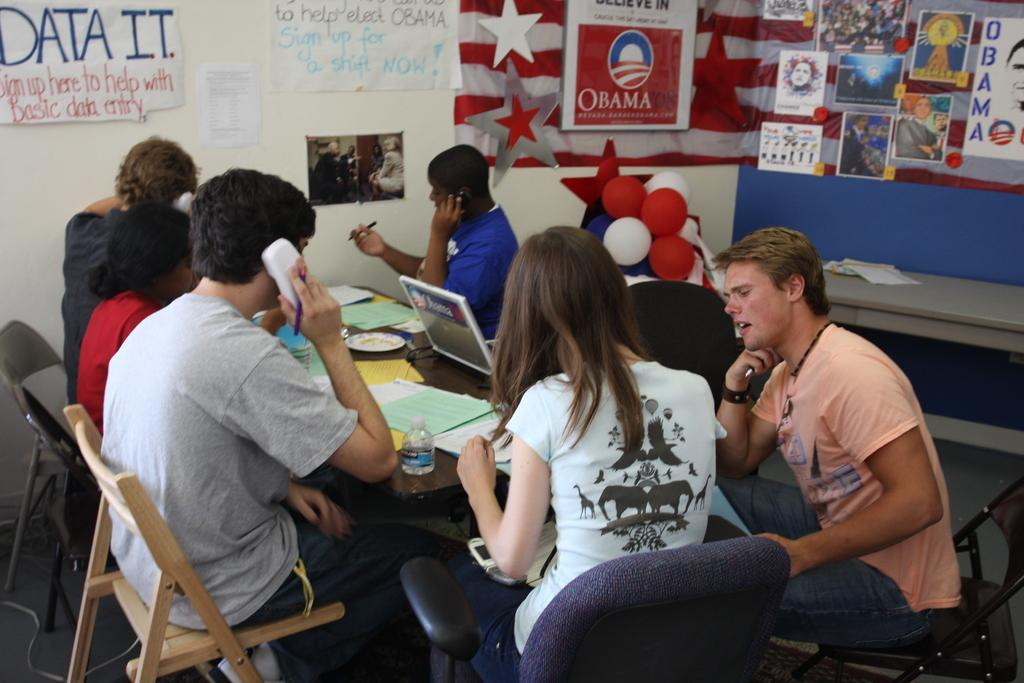What are the people in the image doing? There is a group of people sitting on chairs in the image. What is in front of the chairs? There is a table in front of the chairs. What items can be seen on the table? Papers and a laptop are present on the table. What can be seen in the background of the image? There is a wall visible in the image. What decorative items are present in the image? Balloons are present in the image. What type of quilt is being used as a tablecloth in the image? There is no quilt present in the image; it features a table with papers and a laptop. Can you tell me how many islands are visible in the image? There are no islands visible in the image. 